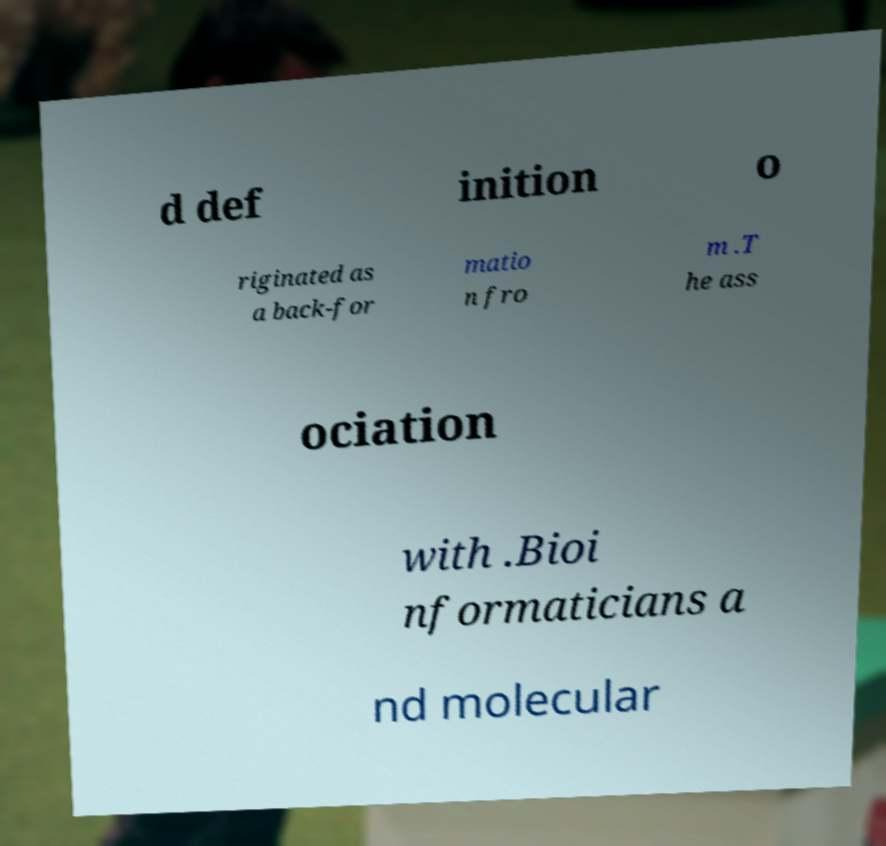For documentation purposes, I need the text within this image transcribed. Could you provide that? d def inition o riginated as a back-for matio n fro m .T he ass ociation with .Bioi nformaticians a nd molecular 